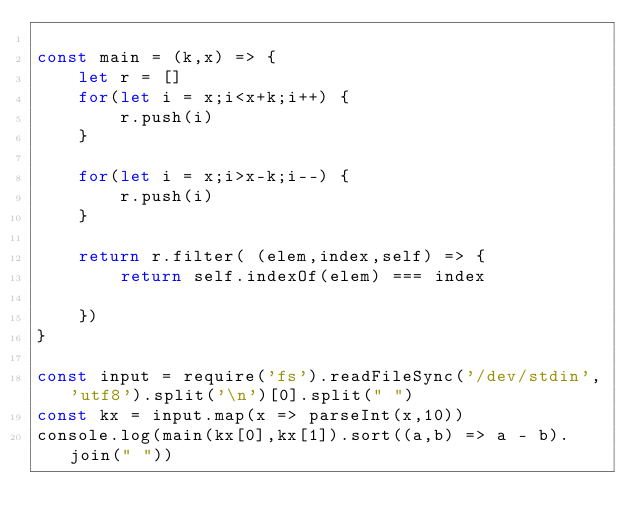<code> <loc_0><loc_0><loc_500><loc_500><_JavaScript_>
const main = (k,x) => {
    let r = []
    for(let i = x;i<x+k;i++) {
        r.push(i)
    }

    for(let i = x;i>x-k;i--) {
        r.push(i)
    }
    
    return r.filter( (elem,index,self) => {
        return self.indexOf(elem) === index

    })
}

const input = require('fs').readFileSync('/dev/stdin','utf8').split('\n')[0].split(" ")
const kx = input.map(x => parseInt(x,10))
console.log(main(kx[0],kx[1]).sort((a,b) => a - b).join(" "))
</code> 